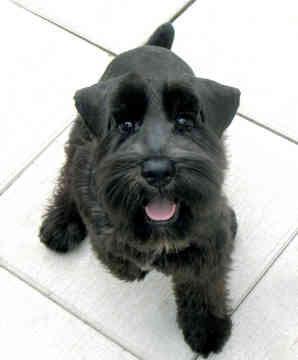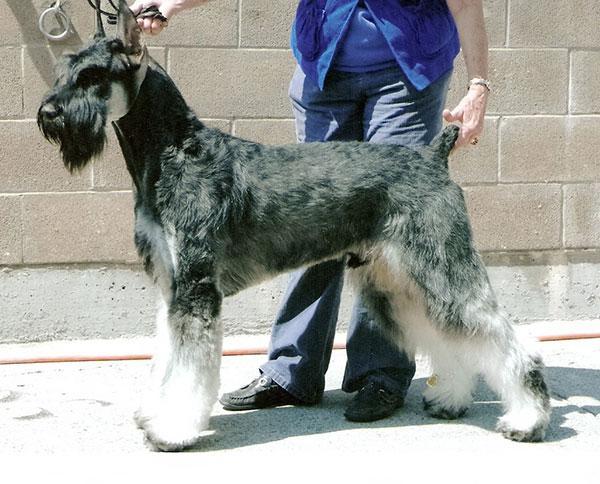The first image is the image on the left, the second image is the image on the right. Assess this claim about the two images: "there is a dog laying in bed". Correct or not? Answer yes or no. No. The first image is the image on the left, the second image is the image on the right. Analyze the images presented: Is the assertion "Each image contains exactly one schnauzer, and one image shows a schnauzer in some type of bed." valid? Answer yes or no. No. 